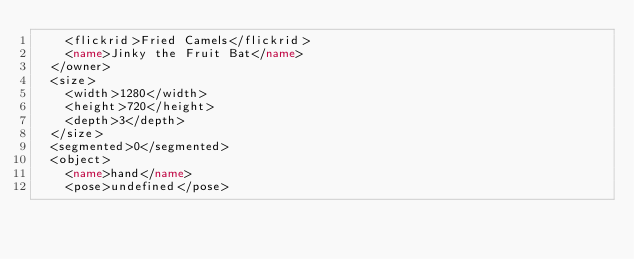<code> <loc_0><loc_0><loc_500><loc_500><_XML_>		<flickrid>Fried Camels</flickrid>
		<name>Jinky the Fruit Bat</name>
	</owner>
	<size>
		<width>1280</width>
		<height>720</height>
		<depth>3</depth>
	</size>
	<segmented>0</segmented>
	<object>
		<name>hand</name>
		<pose>undefined</pose></code> 